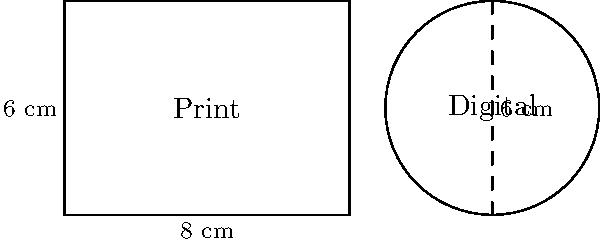A rectangular photograph print measures 8 cm by 6 cm. A circular digital display has a diameter equal to the height of the print. Calculate the difference in area between the rectangular print and the circular display. Express your answer in square centimeters, rounded to two decimal places. To solve this problem, we need to calculate the areas of both the rectangular print and the circular display, then find their difference.

1. Area of the rectangular print:
   $A_{rectangle} = length \times width$
   $A_{rectangle} = 8 \text{ cm} \times 6 \text{ cm} = 48 \text{ cm}^2$

2. Area of the circular display:
   The diameter of the circle is equal to the height of the print, which is 6 cm.
   Therefore, the radius is 3 cm.
   
   $A_{circle} = \pi r^2$
   $A_{circle} = \pi \times (3 \text{ cm})^2 = 9\pi \text{ cm}^2 \approx 28.27 \text{ cm}^2$

3. Difference in area:
   $\text{Difference} = A_{rectangle} - A_{circle}$
   $\text{Difference} = 48 \text{ cm}^2 - 28.27 \text{ cm}^2 = 19.73 \text{ cm}^2$

Rounding to two decimal places, we get 19.73 cm².
Answer: 19.73 cm² 